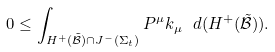<formula> <loc_0><loc_0><loc_500><loc_500>0 \leq \int _ { H ^ { + } ( \tilde { \mathcal { B } } ) \cap J ^ { - } ( \Sigma _ { t } ) } P ^ { \mu } k _ { \mu } \ d ( H ^ { + } ( \tilde { \mathcal { B } } ) ) .</formula> 